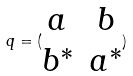Convert formula to latex. <formula><loc_0><loc_0><loc_500><loc_500>q = ( \begin{matrix} a & b \\ b ^ { * } & a ^ { * } \end{matrix} )</formula> 